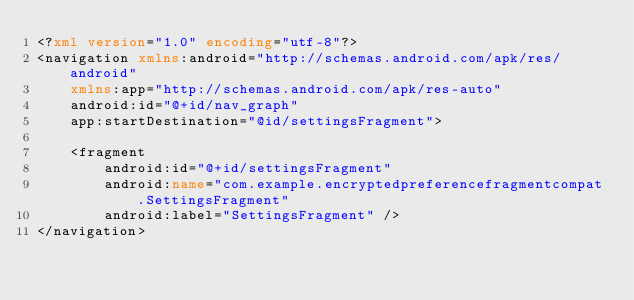<code> <loc_0><loc_0><loc_500><loc_500><_XML_><?xml version="1.0" encoding="utf-8"?>
<navigation xmlns:android="http://schemas.android.com/apk/res/android"
    xmlns:app="http://schemas.android.com/apk/res-auto"
    android:id="@+id/nav_graph"
    app:startDestination="@id/settingsFragment">

    <fragment
        android:id="@+id/settingsFragment"
        android:name="com.example.encryptedpreferencefragmentcompat.SettingsFragment"
        android:label="SettingsFragment" />
</navigation></code> 